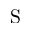Convert formula to latex. <formula><loc_0><loc_0><loc_500><loc_500>S</formula> 